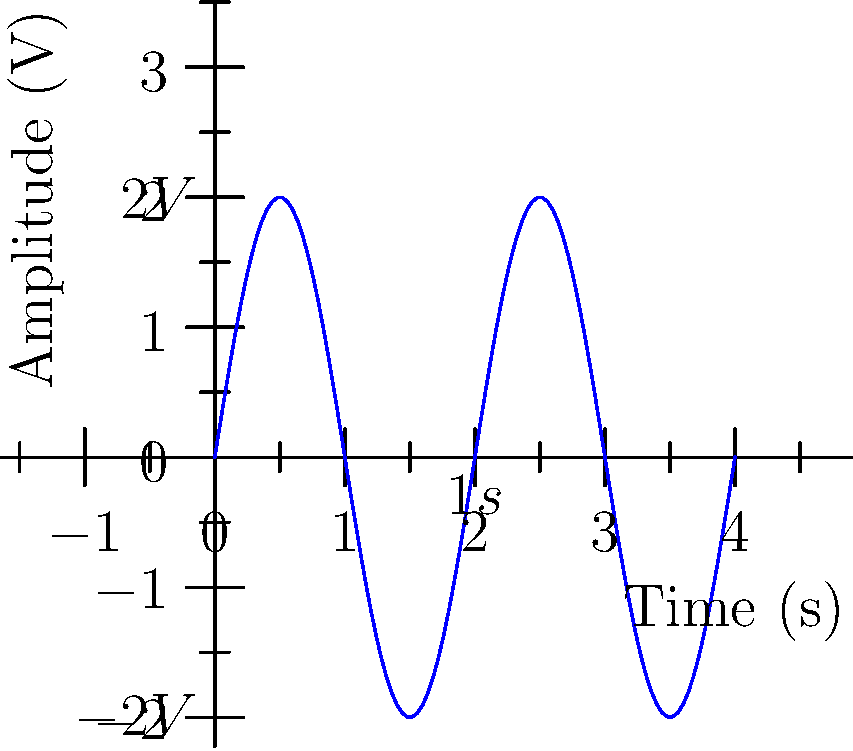As you reflect on James Riley Andrews' life, you notice a sine wave displayed on an oscilloscope in the funeral home. The wave represents his heartbeat recorded during his last moments. Analyze the graph and determine:

a) The amplitude of the sine wave in volts.
b) The frequency of the sine wave in Hz. Let's analyze the sine wave step-by-step:

a) Amplitude:
1. The amplitude is the maximum displacement from the center line.
2. From the graph, we can see the wave extends from -2V to 2V.
3. The amplitude is half of this peak-to-peak value.
4. Therefore, the amplitude is (2V - (-2V))/2 = 4V/2 = 2V.

b) Frequency:
1. The frequency is the number of cycles per second.
2. We need to determine the period (time for one complete cycle) first.
3. From the graph, we can see that one complete cycle takes 2 seconds (the label shows 1s at the midpoint of a cycle).
4. The frequency is the inverse of the period.
5. Frequency = 1 / Period = 1 / 2s = 0.5 Hz.

Thus, the sine wave has an amplitude of 2V and a frequency of 0.5 Hz.
Answer: a) 2V
b) 0.5 Hz 